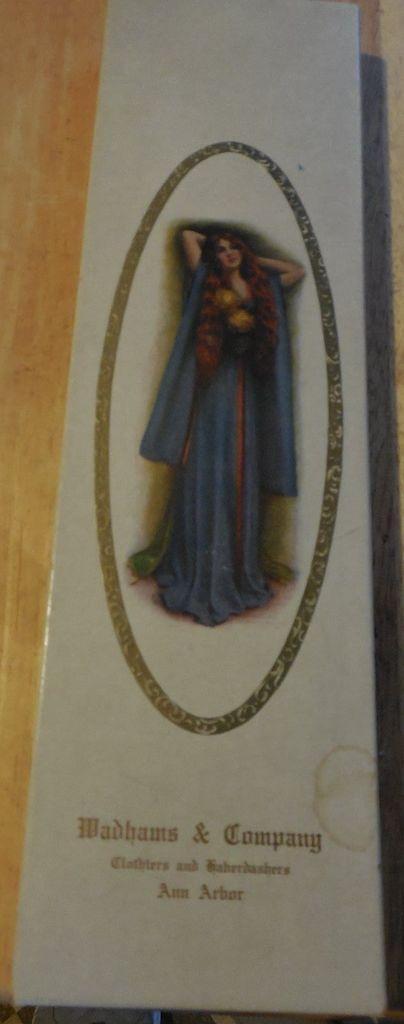Can you describe this image briefly? The picture consists of a poster sticked to a wall. In the poster we can see a woman. At the bottom there is text. 